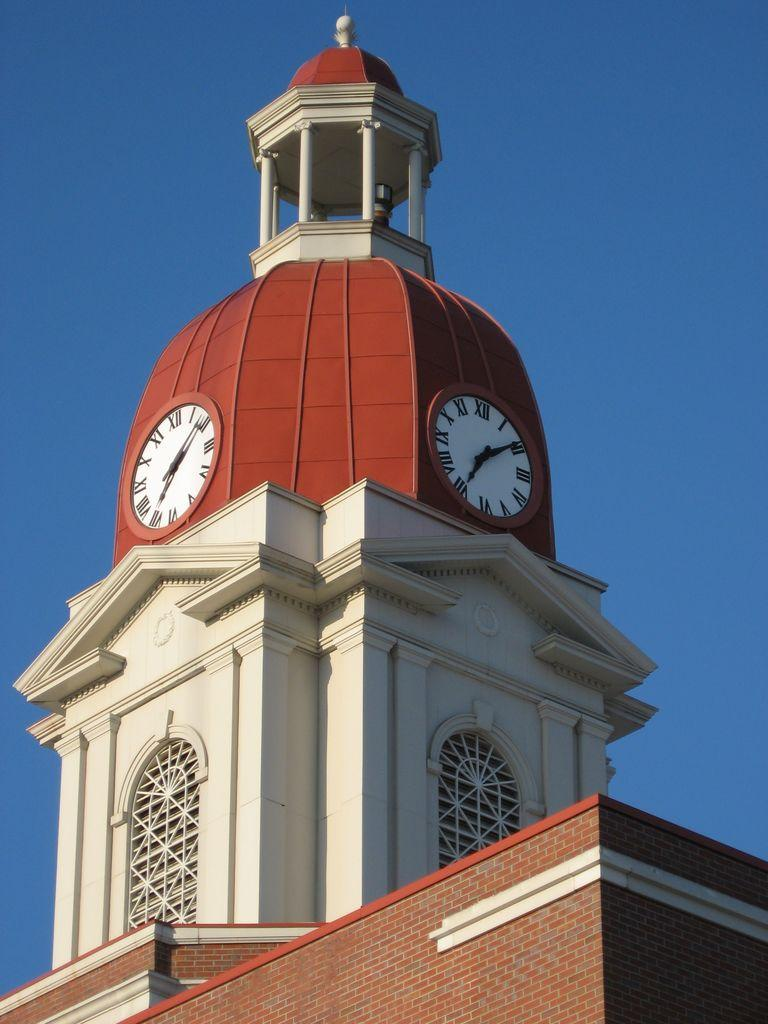What is the main structure in the image? There is a building in the image. What feature can be seen at the top of the building? There are clocks at the top of the building. What is visible at the top of the image? The sky is visible at the top of the image. What type of list can be seen hanging from the wrist of the person in the image? There is no person present in the image, and therefore no list hanging from a wrist. 